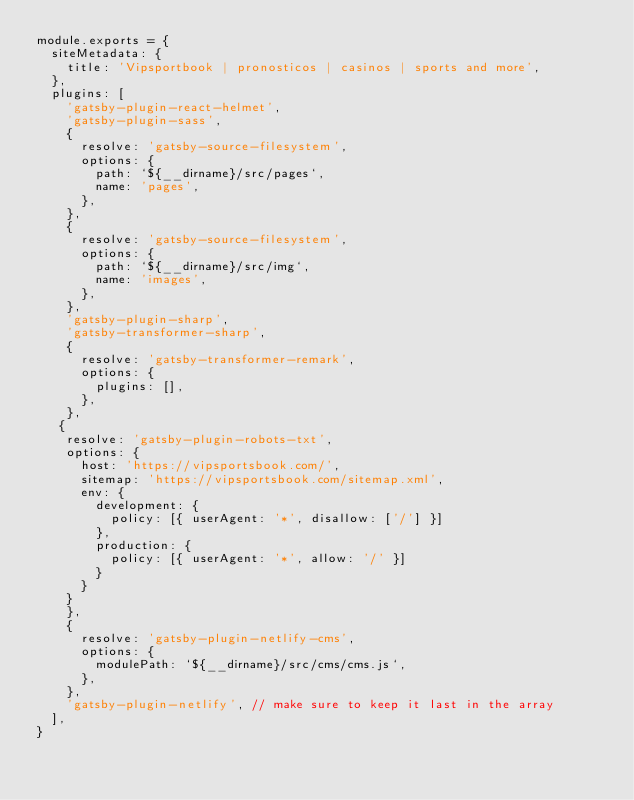<code> <loc_0><loc_0><loc_500><loc_500><_JavaScript_>module.exports = {
  siteMetadata: {
    title: 'Vipsportbook | pronosticos | casinos | sports and more',
  },
  plugins: [
    'gatsby-plugin-react-helmet',
    'gatsby-plugin-sass',
    {
      resolve: 'gatsby-source-filesystem',
      options: {
        path: `${__dirname}/src/pages`,
        name: 'pages',
      },
    },
    {
      resolve: 'gatsby-source-filesystem',
      options: {
        path: `${__dirname}/src/img`,
        name: 'images',
      },
    },
    'gatsby-plugin-sharp',
    'gatsby-transformer-sharp',
    {
      resolve: 'gatsby-transformer-remark',
      options: {
        plugins: [],
      },
    },
   {
    resolve: 'gatsby-plugin-robots-txt',
    options: {
      host: 'https://vipsportsbook.com/',
      sitemap: 'https://vipsportsbook.com/sitemap.xml',
      env: {
        development: {
          policy: [{ userAgent: '*', disallow: ['/'] }]
        },
        production: {
          policy: [{ userAgent: '*', allow: '/' }]
        }
      }
    }
    },
    {
      resolve: 'gatsby-plugin-netlify-cms',
      options: {
        modulePath: `${__dirname}/src/cms/cms.js`,
      },
    },
    'gatsby-plugin-netlify', // make sure to keep it last in the array
  ],
}
</code> 